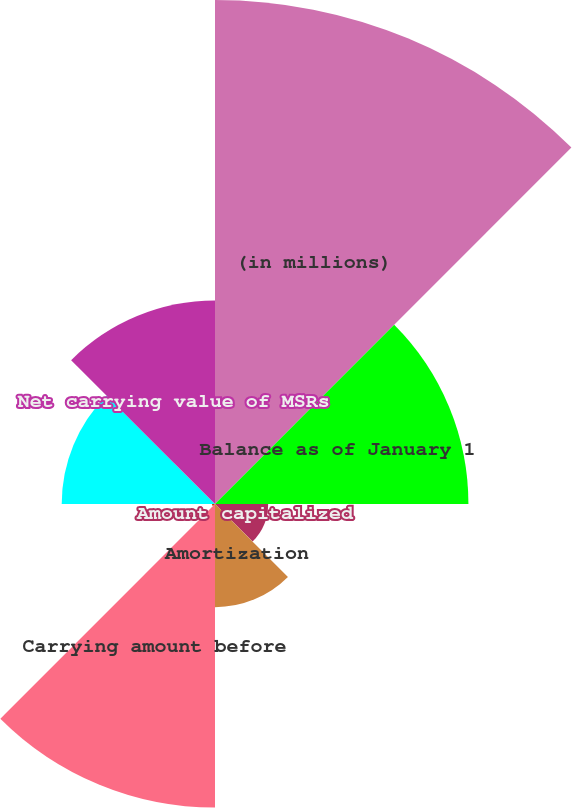Convert chart to OTSL. <chart><loc_0><loc_0><loc_500><loc_500><pie_chart><fcel>(in millions)<fcel>Balance as of January 1<fcel>Amount capitalized<fcel>Amortization<fcel>Carrying amount before<fcel>Valuation (recovery)<fcel>Balance at end of period<fcel>Net carrying value of MSRs<nl><fcel>31.96%<fcel>16.07%<fcel>3.37%<fcel>6.54%<fcel>19.25%<fcel>0.19%<fcel>9.72%<fcel>12.9%<nl></chart> 